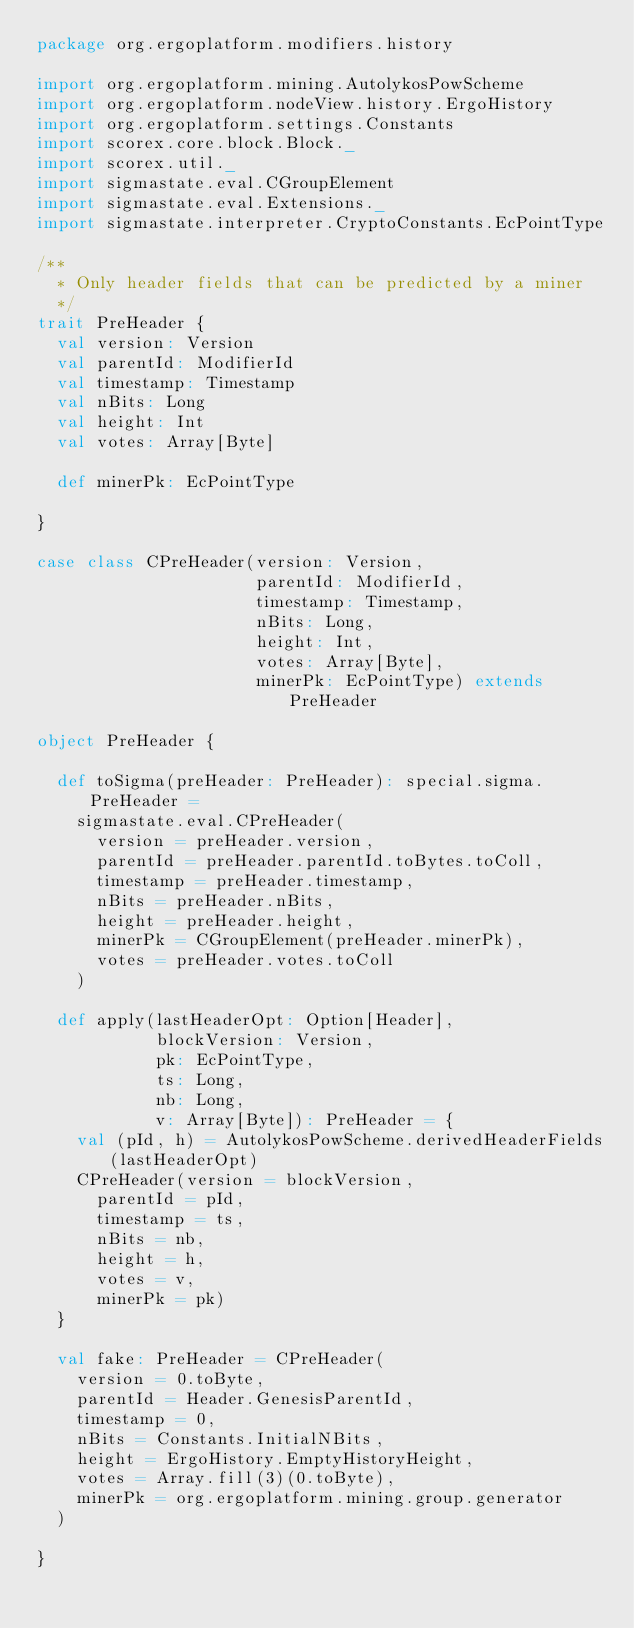Convert code to text. <code><loc_0><loc_0><loc_500><loc_500><_Scala_>package org.ergoplatform.modifiers.history

import org.ergoplatform.mining.AutolykosPowScheme
import org.ergoplatform.nodeView.history.ErgoHistory
import org.ergoplatform.settings.Constants
import scorex.core.block.Block._
import scorex.util._
import sigmastate.eval.CGroupElement
import sigmastate.eval.Extensions._
import sigmastate.interpreter.CryptoConstants.EcPointType

/**
  * Only header fields that can be predicted by a miner
  */
trait PreHeader {
  val version: Version
  val parentId: ModifierId
  val timestamp: Timestamp
  val nBits: Long
  val height: Int
  val votes: Array[Byte]

  def minerPk: EcPointType

}

case class CPreHeader(version: Version,
                      parentId: ModifierId,
                      timestamp: Timestamp,
                      nBits: Long,
                      height: Int,
                      votes: Array[Byte],
                      minerPk: EcPointType) extends PreHeader

object PreHeader {

  def toSigma(preHeader: PreHeader): special.sigma.PreHeader =
    sigmastate.eval.CPreHeader(
      version = preHeader.version,
      parentId = preHeader.parentId.toBytes.toColl,
      timestamp = preHeader.timestamp,
      nBits = preHeader.nBits,
      height = preHeader.height,
      minerPk = CGroupElement(preHeader.minerPk),
      votes = preHeader.votes.toColl
    )

  def apply(lastHeaderOpt: Option[Header],
            blockVersion: Version,
            pk: EcPointType,
            ts: Long,
            nb: Long,
            v: Array[Byte]): PreHeader = {
    val (pId, h) = AutolykosPowScheme.derivedHeaderFields(lastHeaderOpt)
    CPreHeader(version = blockVersion,
      parentId = pId,
      timestamp = ts,
      nBits = nb,
      height = h,
      votes = v,
      minerPk = pk)
  }

  val fake: PreHeader = CPreHeader(
    version = 0.toByte,
    parentId = Header.GenesisParentId,
    timestamp = 0,
    nBits = Constants.InitialNBits,
    height = ErgoHistory.EmptyHistoryHeight,
    votes = Array.fill(3)(0.toByte),
    minerPk = org.ergoplatform.mining.group.generator
  )

}
</code> 